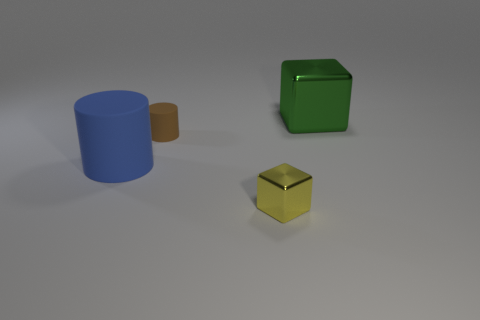Is there anything else that has the same size as the brown matte cylinder?
Ensure brevity in your answer.  Yes. Do the yellow metallic cube and the blue thing that is in front of the large green thing have the same size?
Keep it short and to the point. No. Are there fewer small yellow things that are in front of the yellow metal cube than big blue rubber things?
Your response must be concise. Yes. What number of tiny things are the same color as the large metal thing?
Ensure brevity in your answer.  0. Is the number of large green shiny things less than the number of small cyan shiny things?
Offer a very short reply. No. Do the tiny cylinder and the big cylinder have the same material?
Give a very brief answer. Yes. How many other things are there of the same size as the blue matte thing?
Offer a very short reply. 1. There is a metallic cube behind the shiny block that is in front of the large block; what color is it?
Provide a succinct answer. Green. What number of other objects are the same shape as the tiny brown object?
Provide a short and direct response. 1. Are there any large blocks made of the same material as the small cube?
Ensure brevity in your answer.  Yes. 